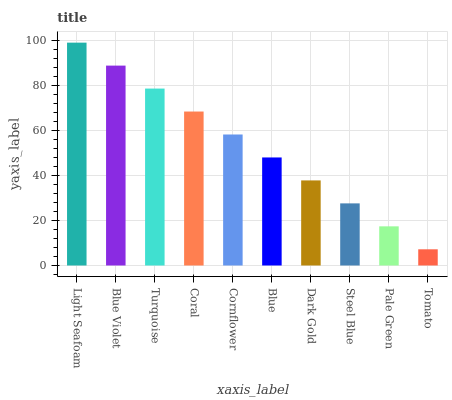Is Tomato the minimum?
Answer yes or no. Yes. Is Light Seafoam the maximum?
Answer yes or no. Yes. Is Blue Violet the minimum?
Answer yes or no. No. Is Blue Violet the maximum?
Answer yes or no. No. Is Light Seafoam greater than Blue Violet?
Answer yes or no. Yes. Is Blue Violet less than Light Seafoam?
Answer yes or no. Yes. Is Blue Violet greater than Light Seafoam?
Answer yes or no. No. Is Light Seafoam less than Blue Violet?
Answer yes or no. No. Is Cornflower the high median?
Answer yes or no. Yes. Is Blue the low median?
Answer yes or no. Yes. Is Dark Gold the high median?
Answer yes or no. No. Is Light Seafoam the low median?
Answer yes or no. No. 